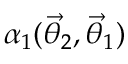<formula> <loc_0><loc_0><loc_500><loc_500>\alpha _ { 1 } ( { \vec { \theta } } _ { 2 } , { \vec { \theta } } _ { 1 } )</formula> 